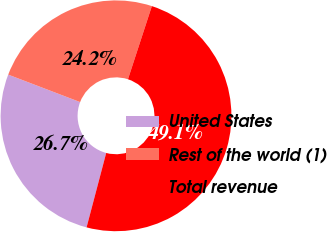Convert chart to OTSL. <chart><loc_0><loc_0><loc_500><loc_500><pie_chart><fcel>United States<fcel>Rest of the world (1)<fcel>Total revenue<nl><fcel>26.7%<fcel>24.22%<fcel>49.08%<nl></chart> 